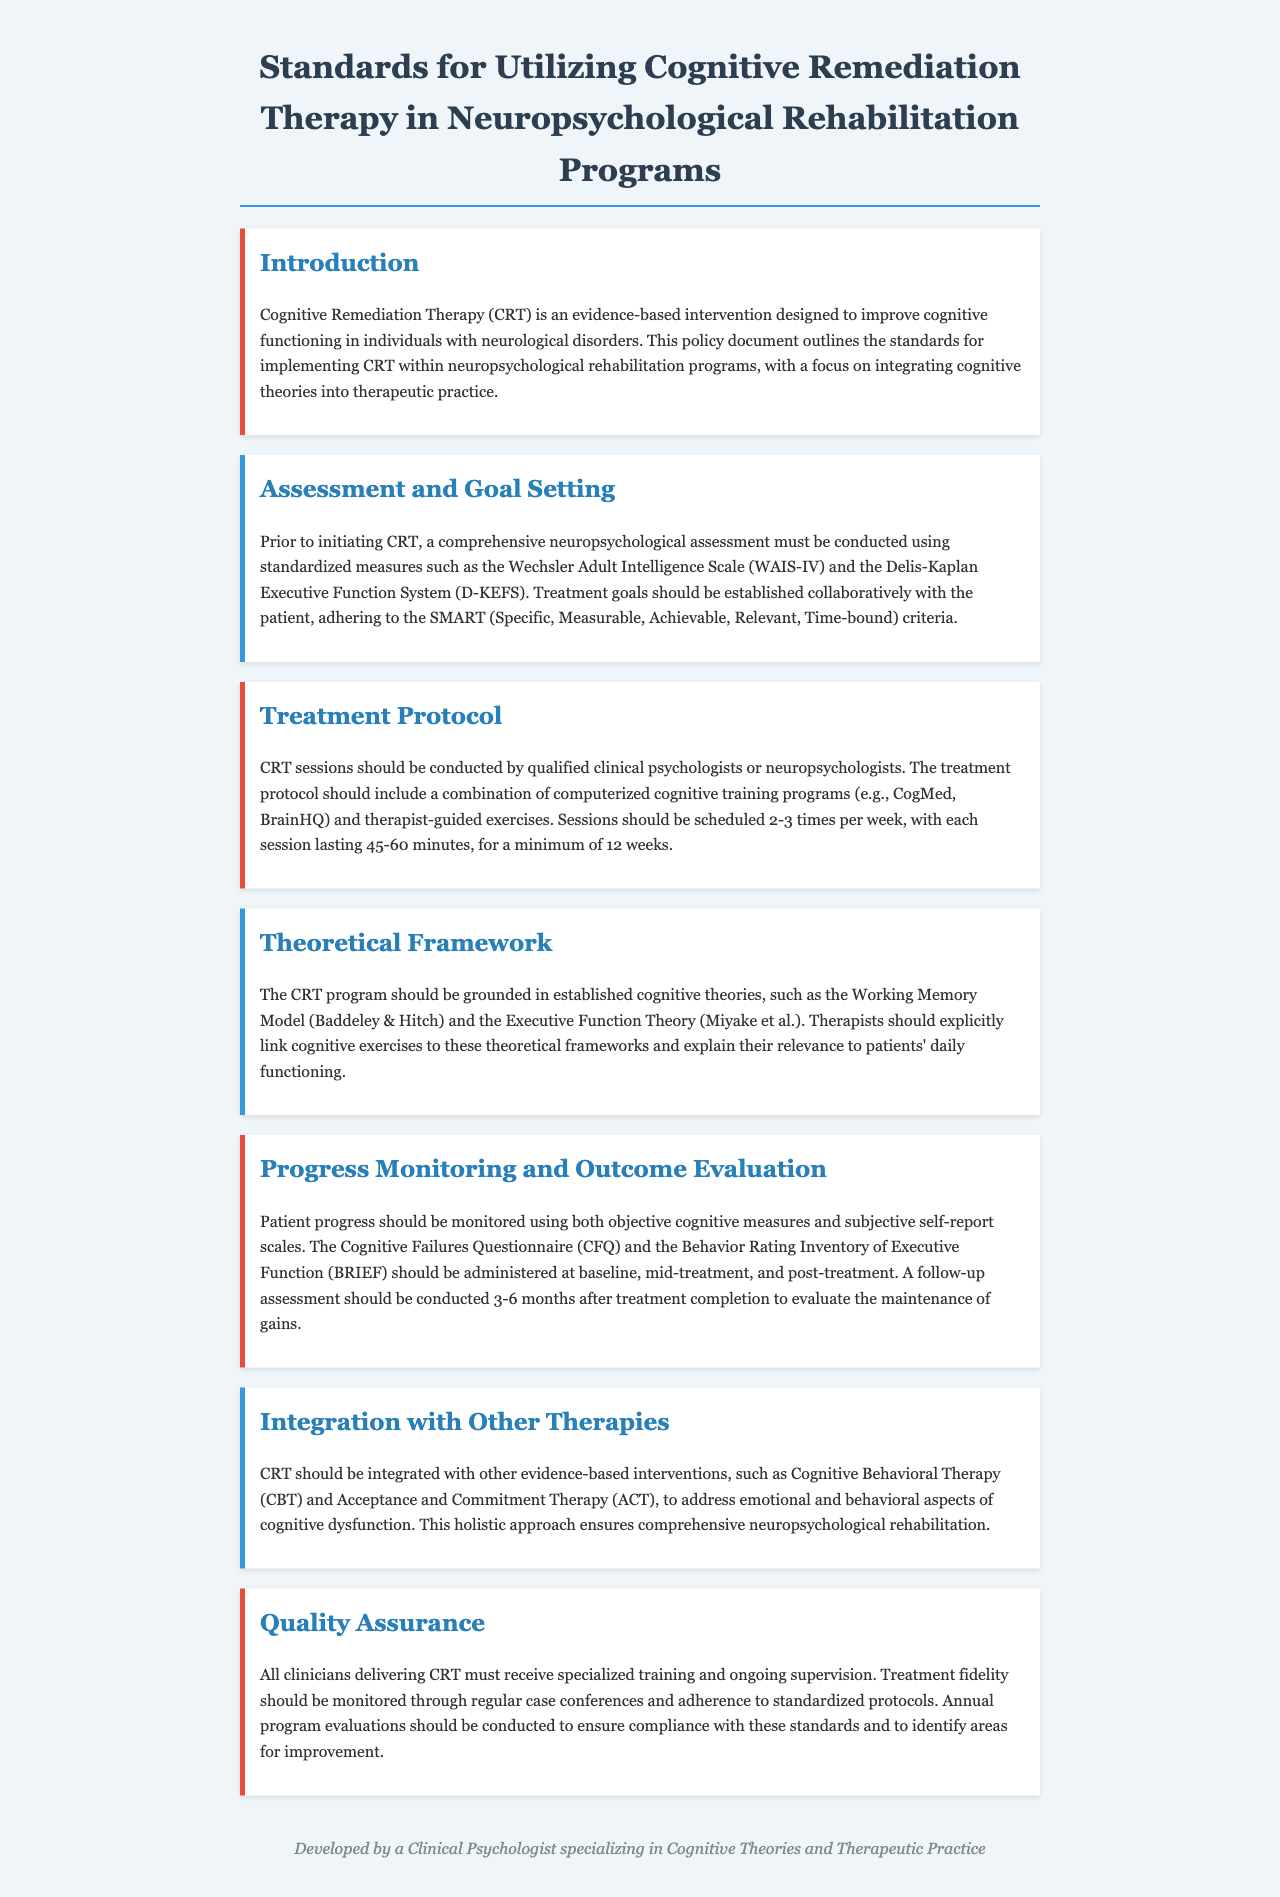What is the main focus of the policy document? The main focus is outlined in the introduction, emphasizing the integration of cognitive theories into therapeutic practice for CRT.
Answer: integration of cognitive theories into therapeutic practice How often should CRT sessions be scheduled? The treatment protocol specifies that sessions should be scheduled 2-3 times per week.
Answer: 2-3 times per week Which cognitive assessment tools are recommended? The document mentions standardized measures, specifically the Wechsler Adult Intelligence Scale (WAIS-IV) and Delis-Kaplan Executive Function System (D-KEFS).
Answer: WAIS-IV and D-KEFS What should treatment goals adhere to? The document outlines that treatment goals should adhere to the SMART criteria (Specific, Measurable, Achievable, Relevant, Time-bound).
Answer: SMART criteria What are the follow-up assessment timelines after treatment? The document states a follow-up assessment should be conducted 3-6 months after treatment completion.
Answer: 3-6 months Which cognitive theories are the CRT program grounded in? The theoretical framework section indicates the CRT program should be grounded in the Working Memory Model and Executive Function Theory.
Answer: Working Memory Model and Executive Function Theory What is required of clinicians delivering CRT? According to the quality assurance section, all clinicians must receive specialized training and ongoing supervision.
Answer: specialized training and ongoing supervision What scale is used for subjective self-report monitoring? The document specifies the Cognitive Failures Questionnaire (CFQ) for subjective self-report monitoring.
Answer: Cognitive Failures Questionnaire (CFQ) 